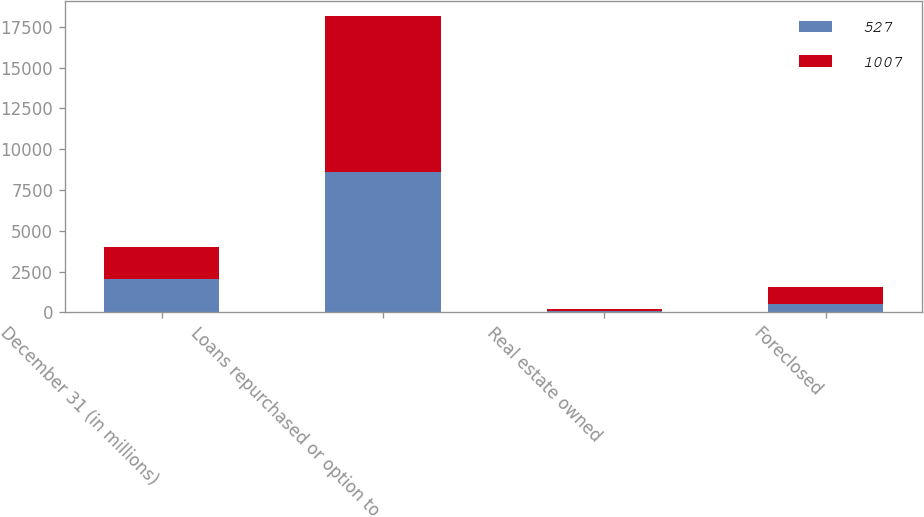Convert chart to OTSL. <chart><loc_0><loc_0><loc_500><loc_500><stacked_bar_chart><ecel><fcel>December 31 (in millions)<fcel>Loans repurchased or option to<fcel>Real estate owned<fcel>Foreclosed<nl><fcel>527<fcel>2017<fcel>8629<fcel>95<fcel>527<nl><fcel>1007<fcel>2016<fcel>9556<fcel>142<fcel>1007<nl></chart> 